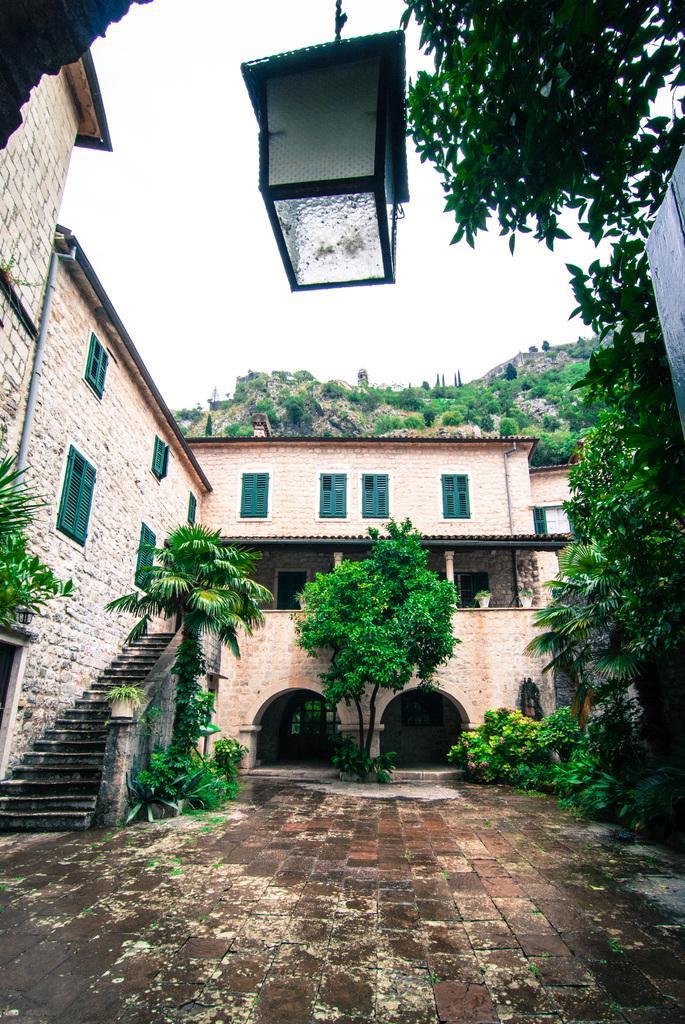Can you describe this image briefly? In this image in the center there are trees. On the right side there are trees and there is a wall. In the front on the top there is an object which is black in colour hanging and in the background there are trees and there is building and the sky is cloudy. 